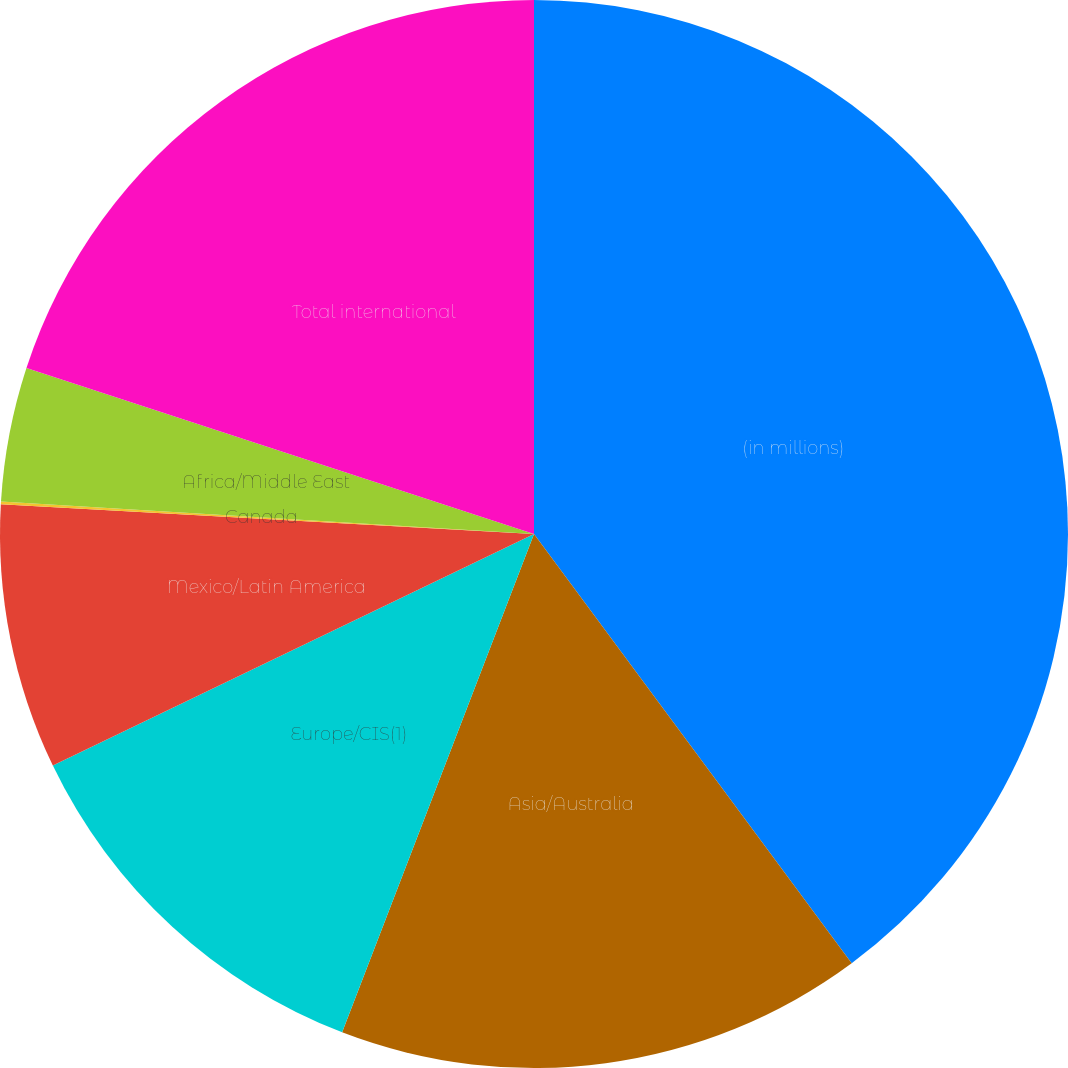Convert chart. <chart><loc_0><loc_0><loc_500><loc_500><pie_chart><fcel>(in millions)<fcel>Asia/Australia<fcel>Europe/CIS(1)<fcel>Mexico/Latin America<fcel>Canada<fcel>Africa/Middle East<fcel>Total international<nl><fcel>39.86%<fcel>15.99%<fcel>12.01%<fcel>8.03%<fcel>0.08%<fcel>4.06%<fcel>19.97%<nl></chart> 